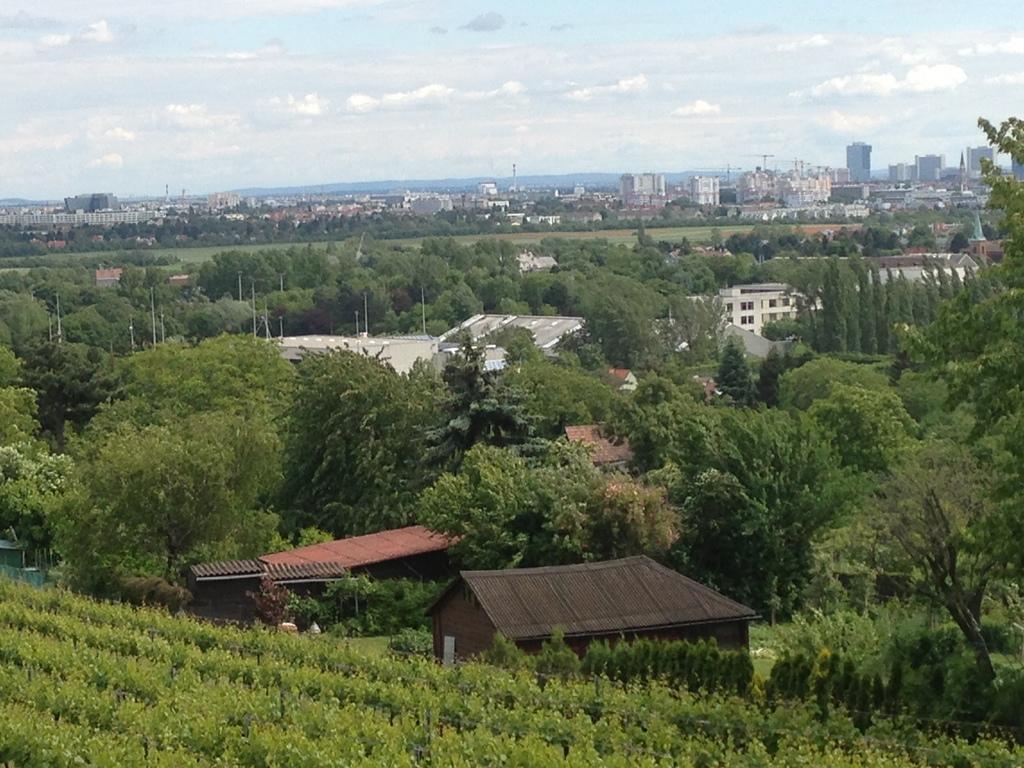Can you describe this image briefly? In this picture I can see buildings, trees and poles. In the background I can see the sky. 